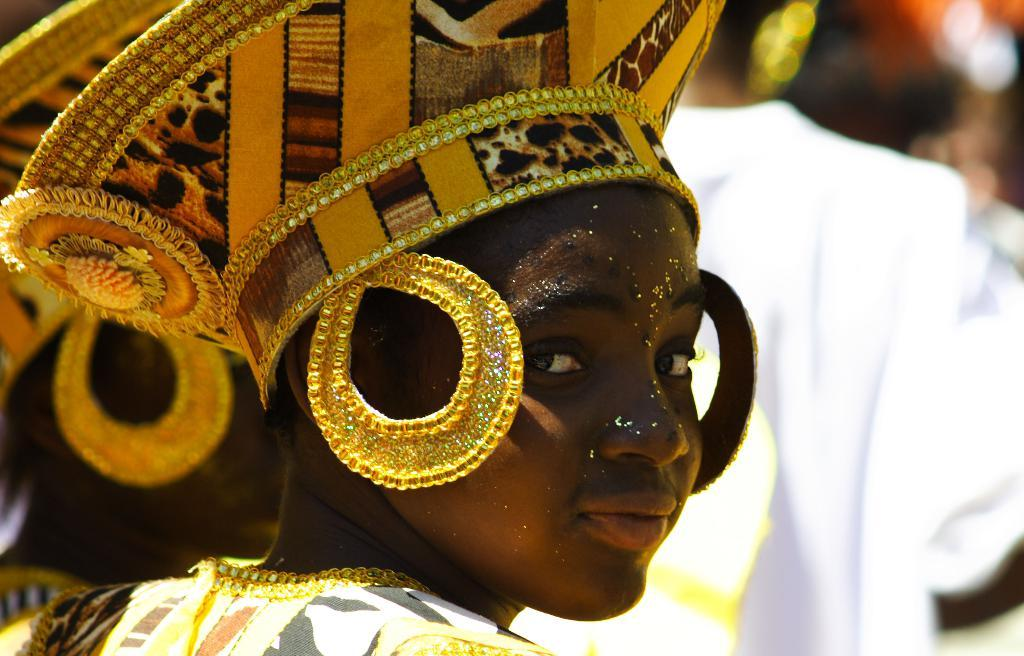What is the main subject of the image? There is a person in the image. What is the person wearing? The person is wearing a different costume. Can you describe the background of the image? The background of the image is blurred. What grade does the appliance receive in the image? There is no appliance present in the image, so it cannot receive a grade. 